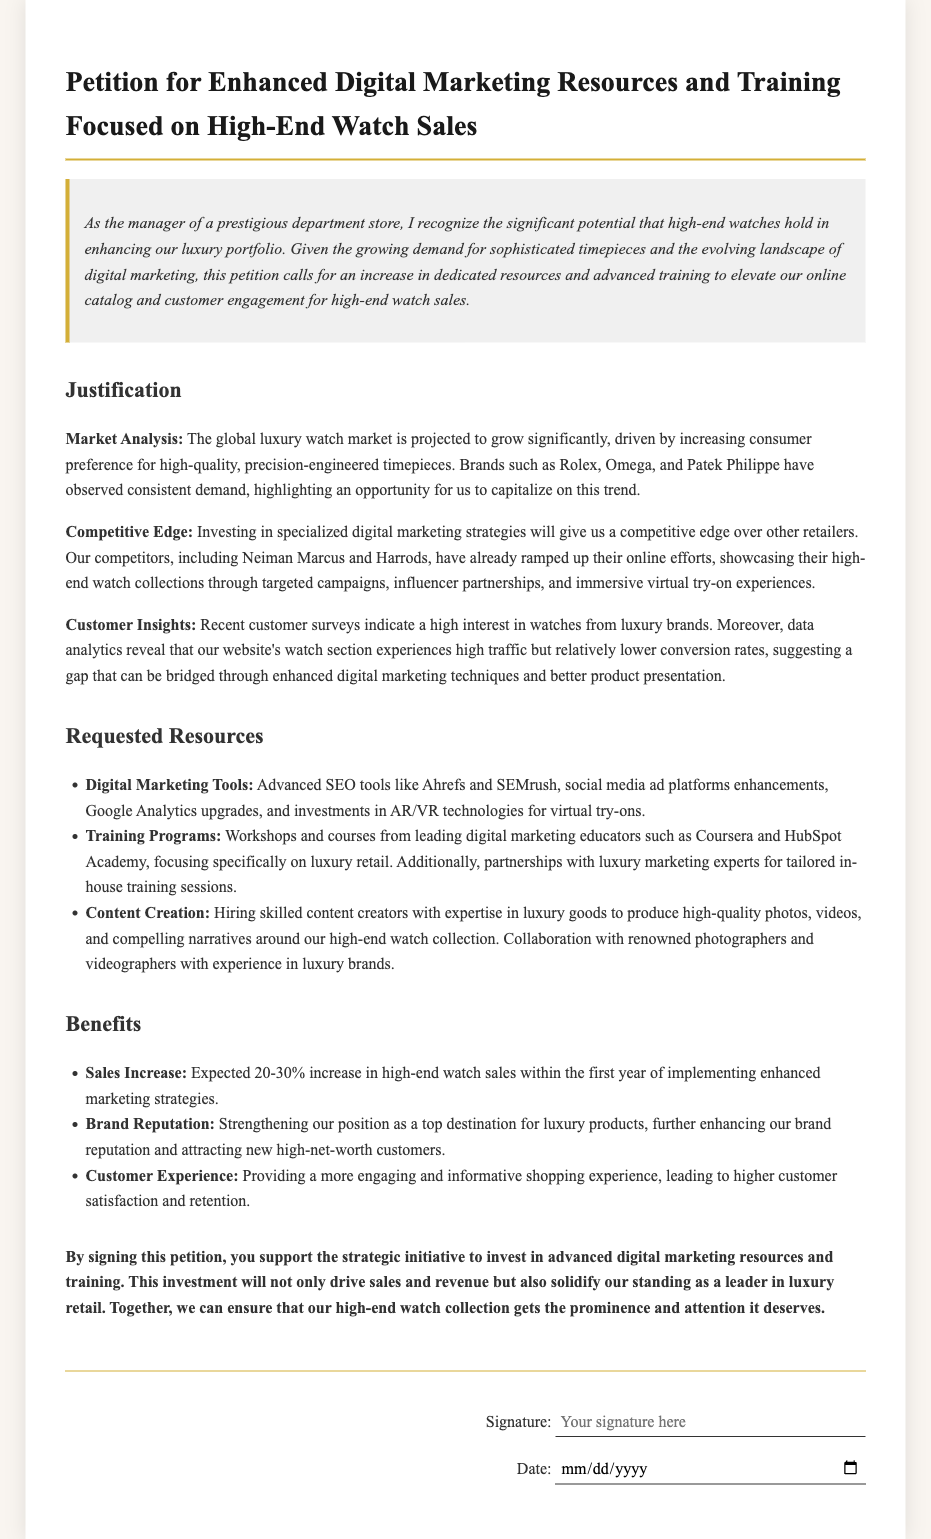What is the title of the petition? The title is clearly stated at the beginning of the document, summarizing its purpose.
Answer: Petition for Enhanced Digital Marketing Resources and Training Focused on High-End Watch Sales What is the projected sales increase? The document mentions the expected increase in high-end watch sales as a percentage.
Answer: 20-30% Which brands are mentioned as examples of luxury watches? The document provides specific examples of luxury watch brands to support its claims.
Answer: Rolex, Omega, Patek Philippe What type of training programs are requested? The petition outlines specific types of training that are being requested to enhance digital marketing skills.
Answer: Workshops and courses What are two digital marketing tools mentioned in the requested resources? The document details specific tools that are necessary for enhancing digital marketing efforts.
Answer: Ahrefs, SEMrush Why is there a need for enhanced digital marketing strategies? The justification section outlines multiple reasons, emphasizing the competitive landscape.
Answer: Competitive edge What do customer surveys indicate about luxury watches? The document refers to customer survey results to highlight consumer interest in luxury items.
Answer: High interest What is the main goal of signing the petition? The document concludes with the aim of the petition, reflecting the overall objective.
Answer: Support the strategic initiative Who are the competitors mentioned in the competition analysis? The document lists specific competitors that are noted for their digital marketing efforts in luxury retail.
Answer: Neiman Marcus, Harrods 